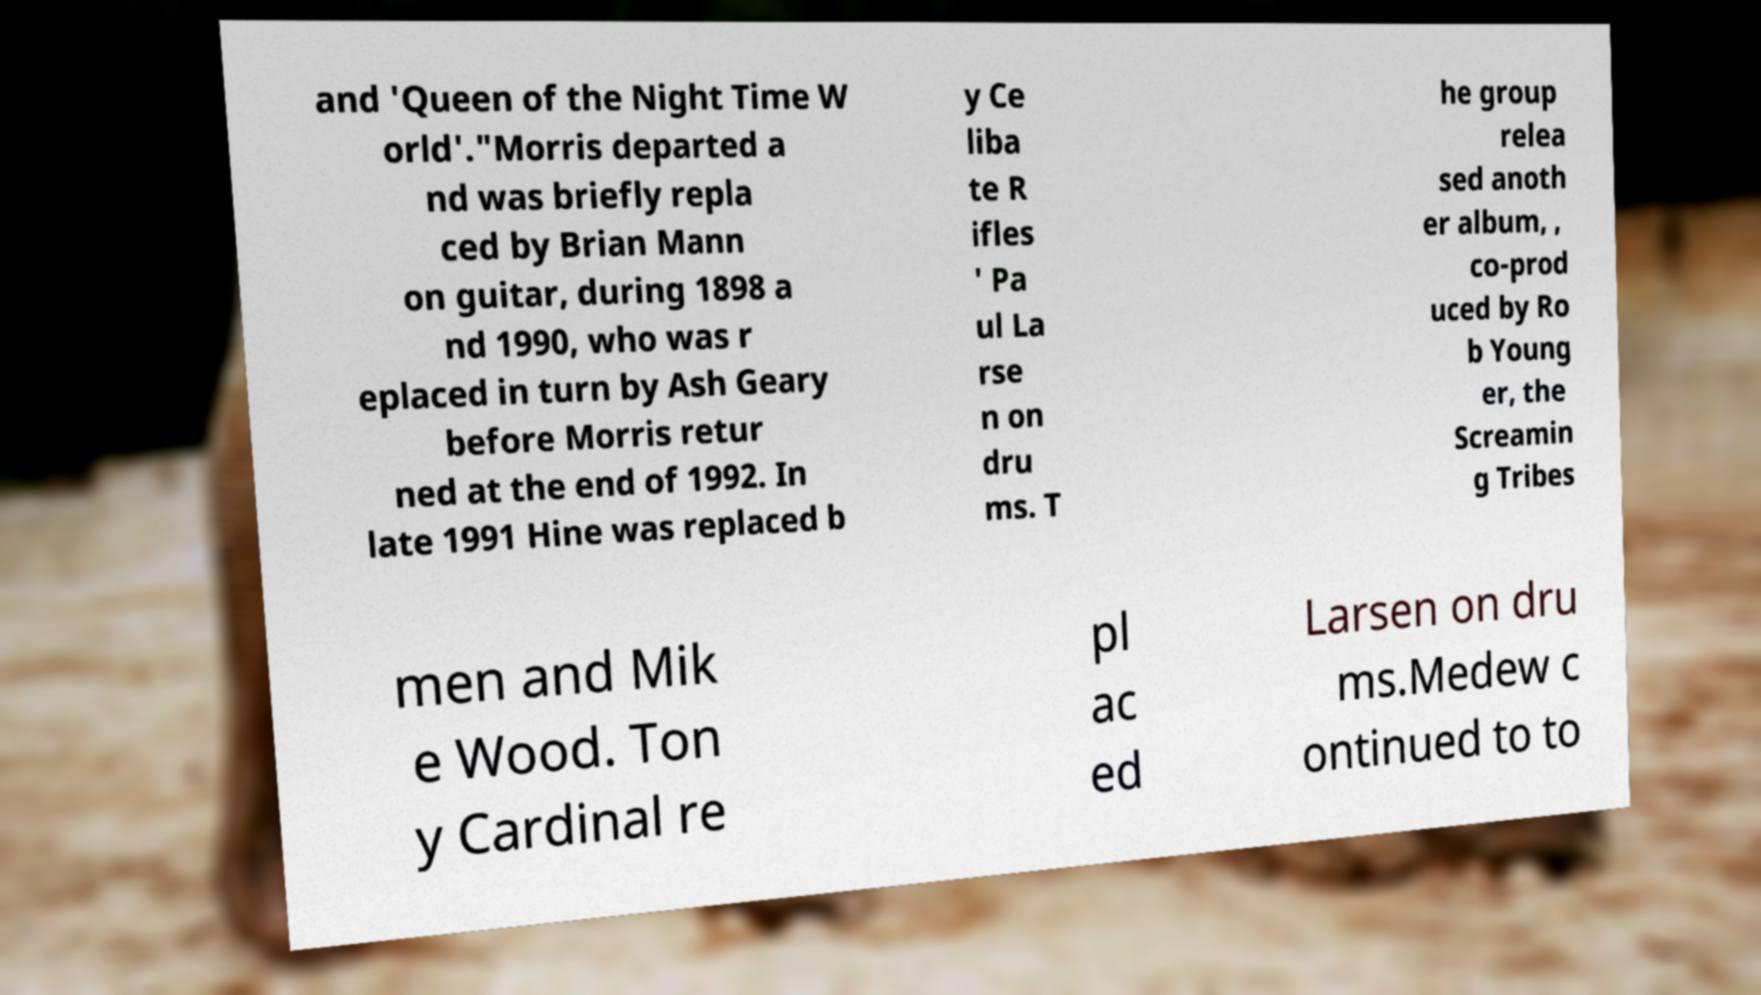There's text embedded in this image that I need extracted. Can you transcribe it verbatim? and 'Queen of the Night Time W orld'."Morris departed a nd was briefly repla ced by Brian Mann on guitar, during 1898 a nd 1990, who was r eplaced in turn by Ash Geary before Morris retur ned at the end of 1992. In late 1991 Hine was replaced b y Ce liba te R ifles ' Pa ul La rse n on dru ms. T he group relea sed anoth er album, , co-prod uced by Ro b Young er, the Screamin g Tribes men and Mik e Wood. Ton y Cardinal re pl ac ed Larsen on dru ms.Medew c ontinued to to 